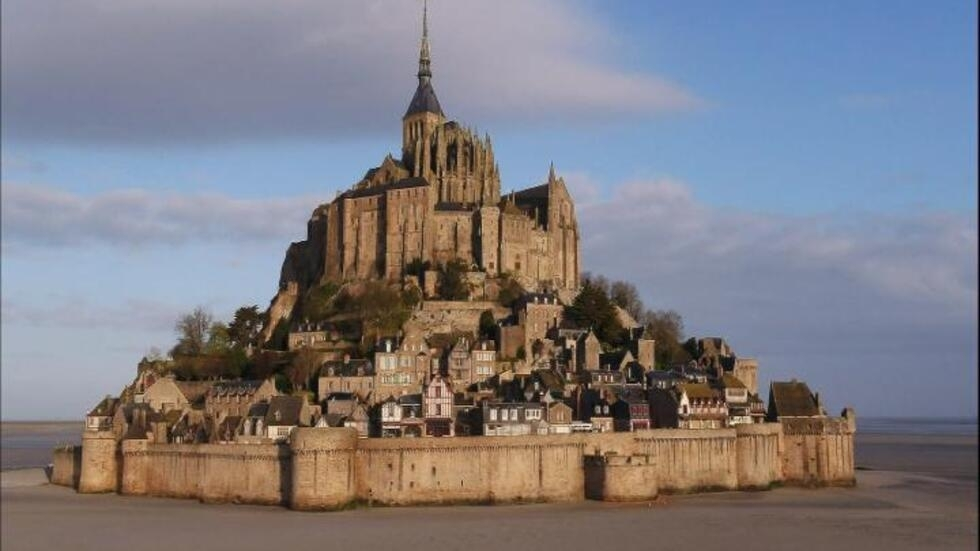Can you suggest a fictional story inspired by this place? Once upon a time, Mont Saint Michel was not just an abbey but a citadel where a secretive order of guardians protected ancient relics endowed with mystical powers. The leader of this order, an enigmatic sorcerer, discovered an impending apocalypse that could be averted only by unearthing a long-lost artifact hidden deep within the abbey’s labyrinthine corridors. This artifact, the 'Heart of the Tides,' was said to command the very seas that surround the island. An adventurous young novice teams up with the sorcerer, navigating secret passages, deciphering cryptic inscriptions, and confronting mythical creatures, all while an ancient evil threatens to unravel the temporal fabric of their world. As they dive deeper into the abbey’s secrets, they uncover not just the artifact, but a long-forgotten history of battles, heroism, and sacrifices that shaped the very existence of Mont Saint Michel. Their journey, filled with adrenaline-pumping action and poignant moments of reflection, will determine the fate of their world. 